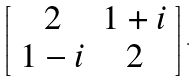Convert formula to latex. <formula><loc_0><loc_0><loc_500><loc_500>\left [ \begin{array} { c c } 2 & 1 + i \\ 1 - i & 2 \\ \end{array} \right ] .</formula> 